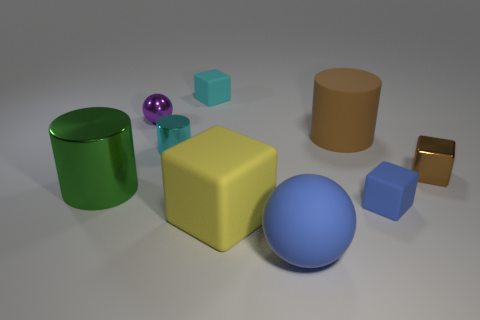There is a cylinder on the left side of the tiny cyan metallic cylinder; what is its color? green 